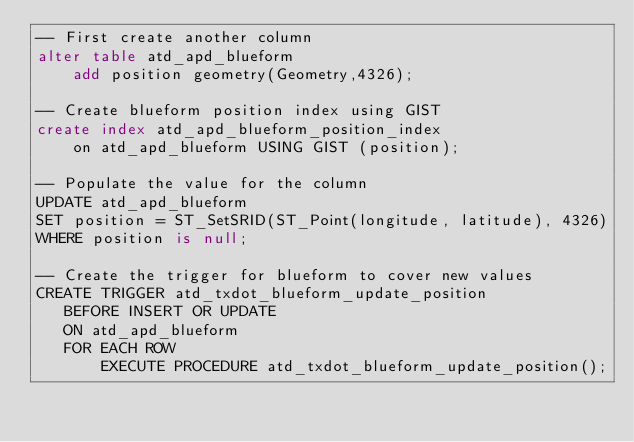Convert code to text. <code><loc_0><loc_0><loc_500><loc_500><_SQL_>-- First create another column
alter table atd_apd_blueform
	add position geometry(Geometry,4326);

-- Create blueform position index using GIST
create index atd_apd_blueform_position_index
	on atd_apd_blueform USING GIST (position);

-- Populate the value for the column
UPDATE atd_apd_blueform
SET position = ST_SetSRID(ST_Point(longitude, latitude), 4326)
WHERE position is null;

-- Create the trigger for blueform to cover new values
CREATE TRIGGER atd_txdot_blueform_update_position
   BEFORE INSERT OR UPDATE
   ON atd_apd_blueform
   FOR EACH ROW
       EXECUTE PROCEDURE atd_txdot_blueform_update_position();
</code> 